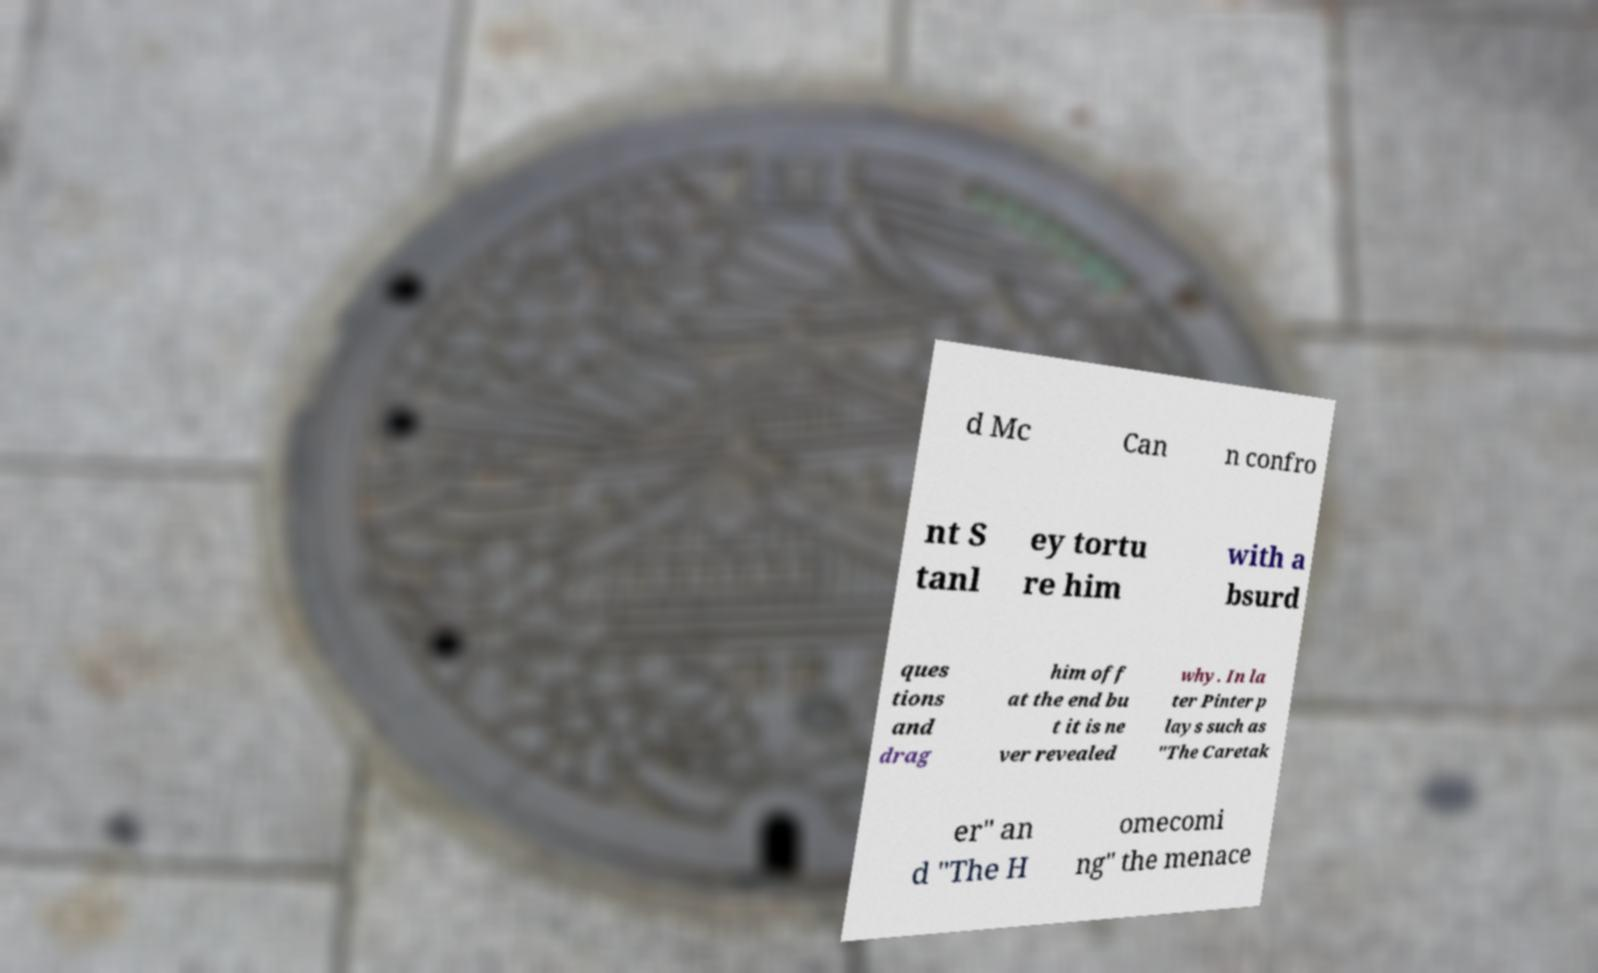Can you accurately transcribe the text from the provided image for me? d Mc Can n confro nt S tanl ey tortu re him with a bsurd ques tions and drag him off at the end bu t it is ne ver revealed why. In la ter Pinter p lays such as "The Caretak er" an d "The H omecomi ng" the menace 